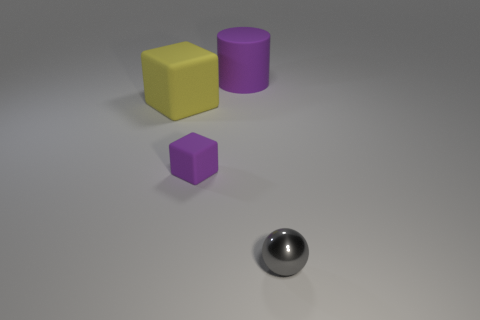Is the number of tiny gray rubber things less than the number of tiny matte things?
Provide a short and direct response. Yes. There is a tiny matte object; does it have the same color as the matte object that is on the right side of the purple rubber block?
Offer a very short reply. Yes. Is the number of big yellow things that are behind the big yellow thing the same as the number of spheres that are on the right side of the large purple cylinder?
Give a very brief answer. No. What number of small matte things are the same shape as the large purple matte object?
Provide a succinct answer. 0. Are there any large cubes?
Your answer should be compact. Yes. Is the material of the large cylinder the same as the thing that is to the right of the large purple cylinder?
Your answer should be compact. No. What is the material of the object that is the same size as the gray sphere?
Make the answer very short. Rubber. Are there any small blocks made of the same material as the purple cylinder?
Your response must be concise. Yes. There is a big cylinder right of the tiny object that is behind the metal ball; is there a gray ball that is in front of it?
Keep it short and to the point. Yes. The purple matte object that is the same size as the gray shiny ball is what shape?
Offer a very short reply. Cube. 